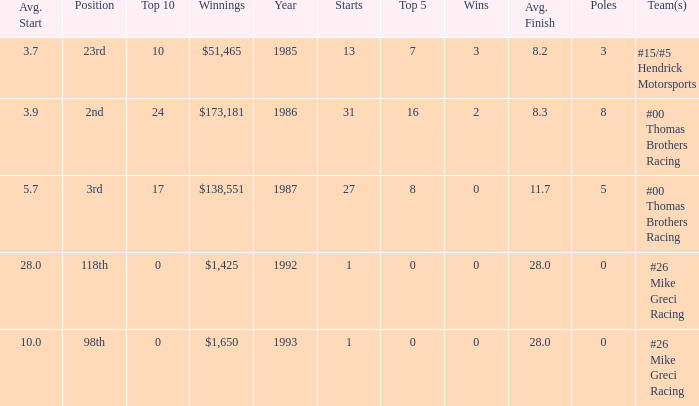What team was Bodine in when he had an average finish of 8.3? #00 Thomas Brothers Racing. 